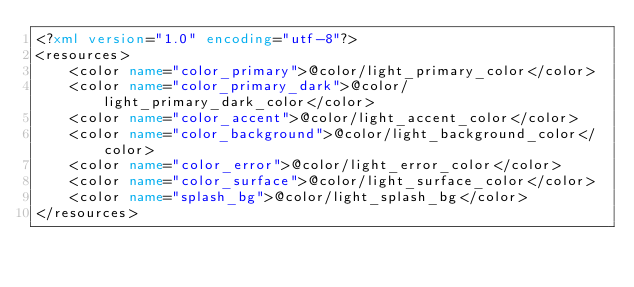Convert code to text. <code><loc_0><loc_0><loc_500><loc_500><_XML_><?xml version="1.0" encoding="utf-8"?>
<resources>
    <color name="color_primary">@color/light_primary_color</color>
    <color name="color_primary_dark">@color/light_primary_dark_color</color>
    <color name="color_accent">@color/light_accent_color</color>
    <color name="color_background">@color/light_background_color</color>
    <color name="color_error">@color/light_error_color</color>
    <color name="color_surface">@color/light_surface_color</color>
    <color name="splash_bg">@color/light_splash_bg</color>
</resources>
</code> 